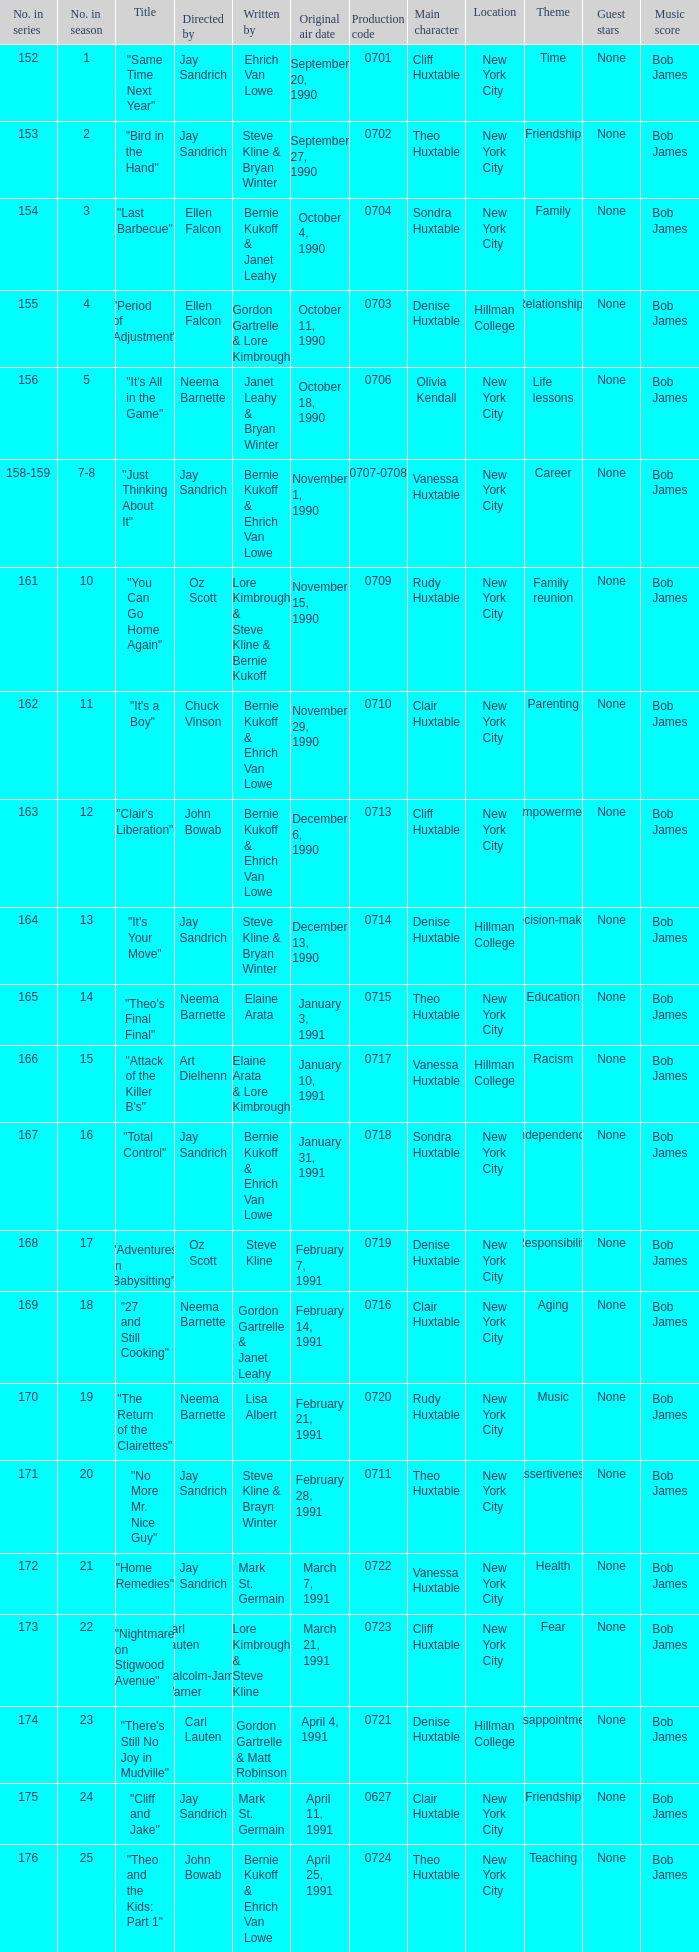The episode "adventures in babysitting" had what number in the season? 17.0. 